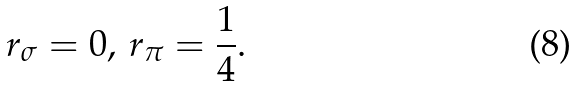<formula> <loc_0><loc_0><loc_500><loc_500>r _ { \sigma } = 0 , \, r _ { \pi } = \frac { 1 } { 4 } .</formula> 